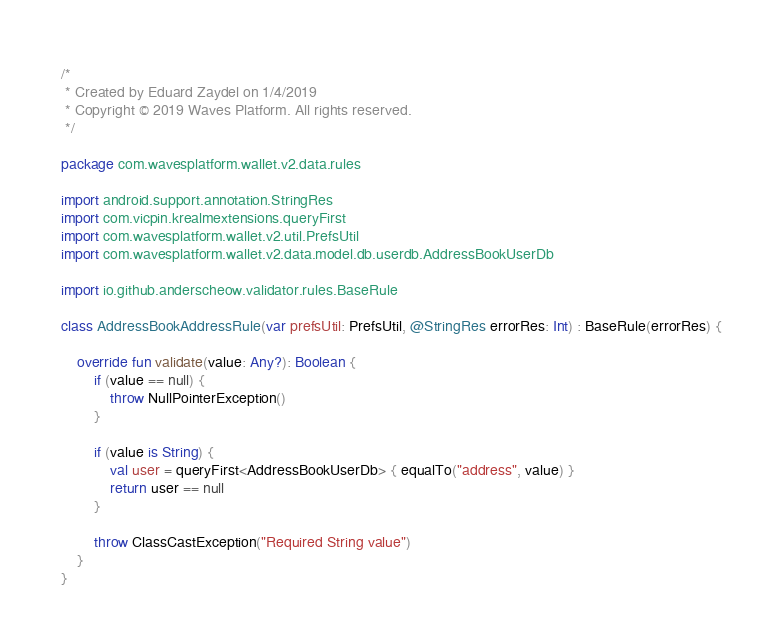<code> <loc_0><loc_0><loc_500><loc_500><_Kotlin_>/*
 * Created by Eduard Zaydel on 1/4/2019
 * Copyright © 2019 Waves Platform. All rights reserved.
 */

package com.wavesplatform.wallet.v2.data.rules

import android.support.annotation.StringRes
import com.vicpin.krealmextensions.queryFirst
import com.wavesplatform.wallet.v2.util.PrefsUtil
import com.wavesplatform.wallet.v2.data.model.db.userdb.AddressBookUserDb

import io.github.anderscheow.validator.rules.BaseRule

class AddressBookAddressRule(var prefsUtil: PrefsUtil, @StringRes errorRes: Int) : BaseRule(errorRes) {

    override fun validate(value: Any?): Boolean {
        if (value == null) {
            throw NullPointerException()
        }

        if (value is String) {
            val user = queryFirst<AddressBookUserDb> { equalTo("address", value) }
            return user == null
        }

        throw ClassCastException("Required String value")
    }
}</code> 